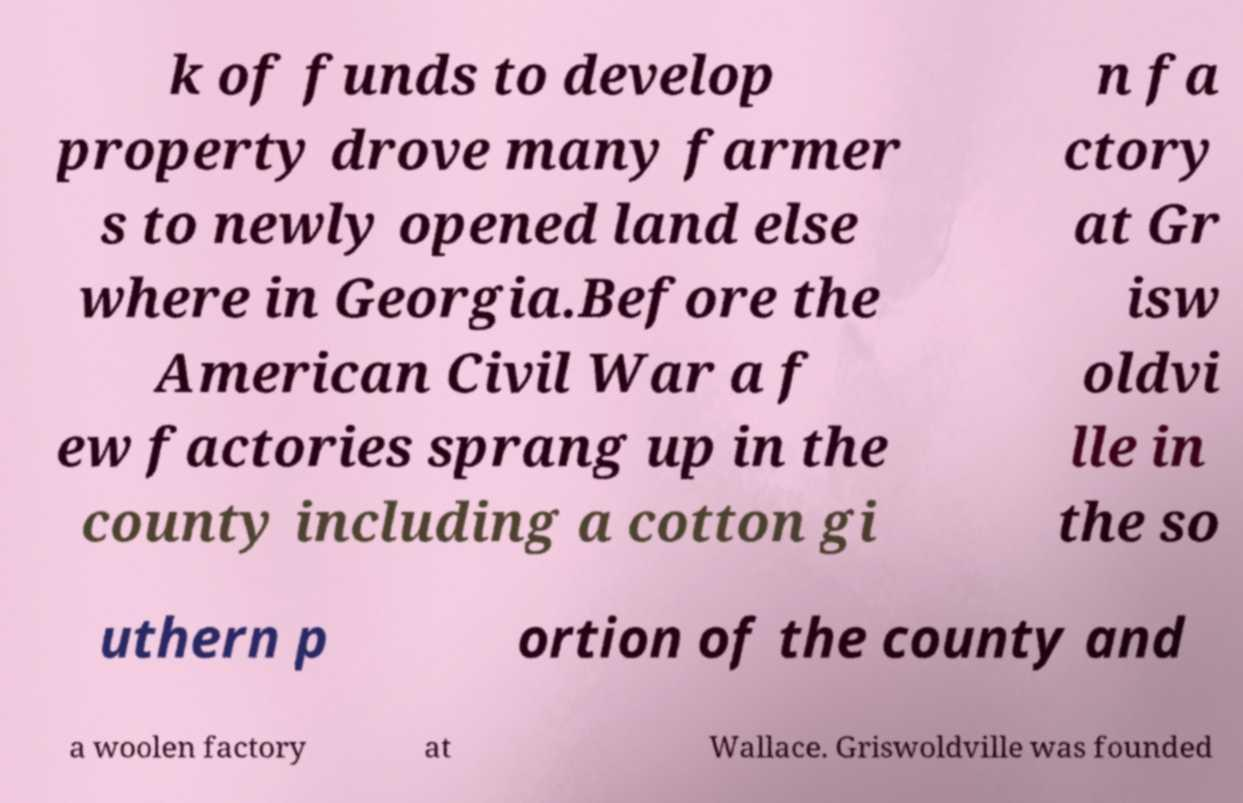I need the written content from this picture converted into text. Can you do that? k of funds to develop property drove many farmer s to newly opened land else where in Georgia.Before the American Civil War a f ew factories sprang up in the county including a cotton gi n fa ctory at Gr isw oldvi lle in the so uthern p ortion of the county and a woolen factory at Wallace. Griswoldville was founded 